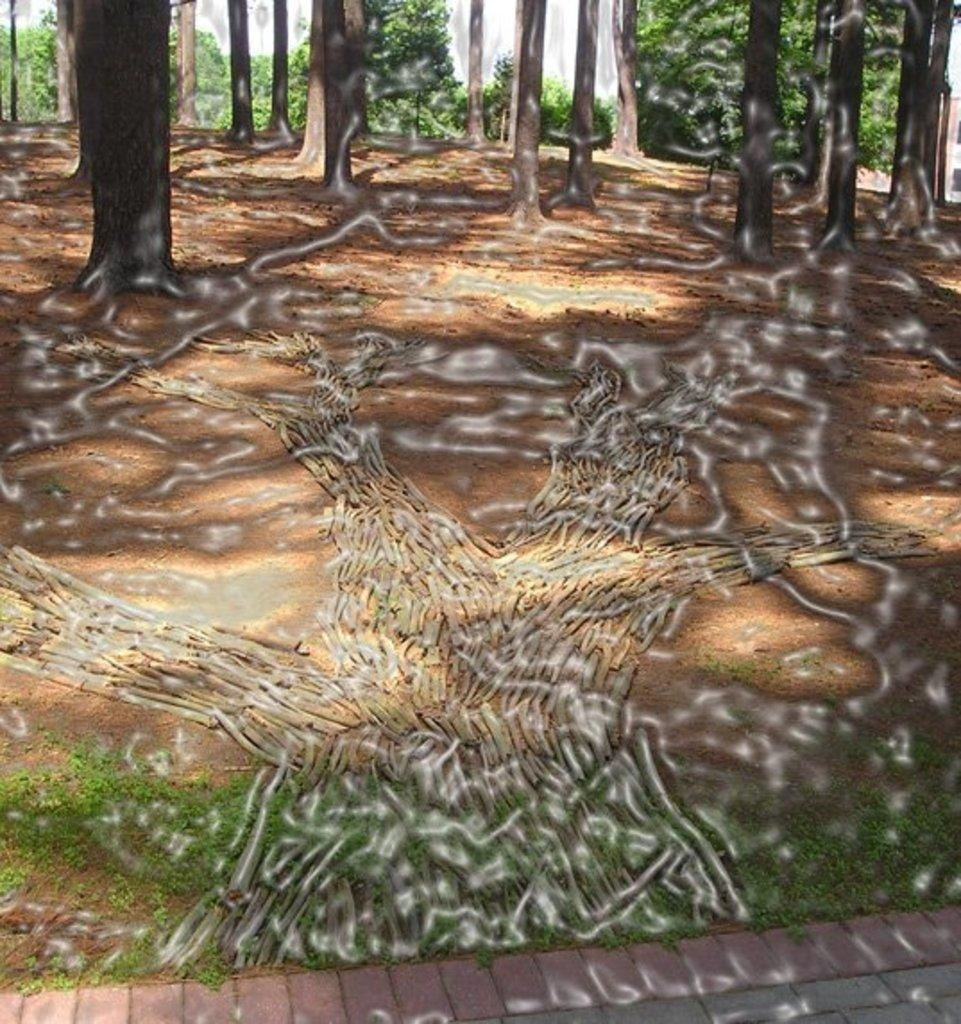What type of vegetation can be seen in the image? There are trees and grass in the image. What part of the plants is visible in the image? Roots are visible in the image. What type of wren can be seen perched on the tree in the image? There is no wren present in the image; only trees, grass, and roots are visible. 